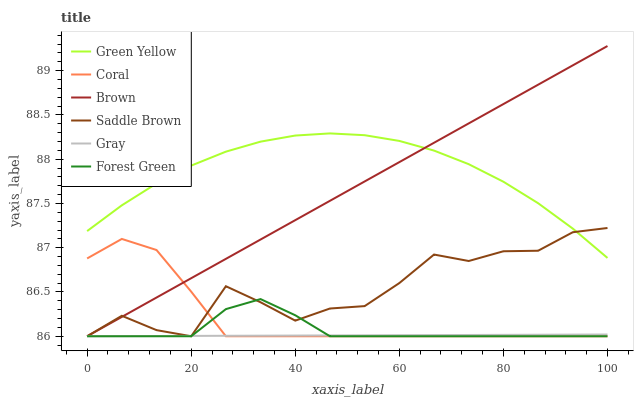Does Gray have the minimum area under the curve?
Answer yes or no. Yes. Does Green Yellow have the maximum area under the curve?
Answer yes or no. Yes. Does Coral have the minimum area under the curve?
Answer yes or no. No. Does Coral have the maximum area under the curve?
Answer yes or no. No. Is Gray the smoothest?
Answer yes or no. Yes. Is Saddle Brown the roughest?
Answer yes or no. Yes. Is Coral the smoothest?
Answer yes or no. No. Is Coral the roughest?
Answer yes or no. No. Does Brown have the lowest value?
Answer yes or no. Yes. Does Green Yellow have the lowest value?
Answer yes or no. No. Does Brown have the highest value?
Answer yes or no. Yes. Does Coral have the highest value?
Answer yes or no. No. Is Gray less than Green Yellow?
Answer yes or no. Yes. Is Green Yellow greater than Forest Green?
Answer yes or no. Yes. Does Coral intersect Brown?
Answer yes or no. Yes. Is Coral less than Brown?
Answer yes or no. No. Is Coral greater than Brown?
Answer yes or no. No. Does Gray intersect Green Yellow?
Answer yes or no. No. 